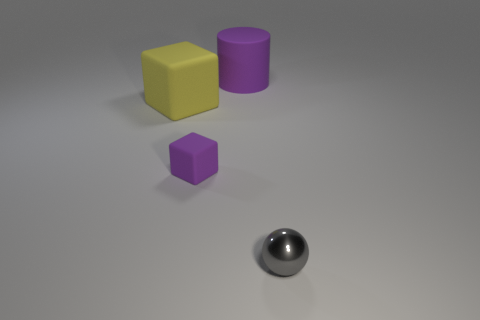Add 2 yellow objects. How many objects exist? 6 Subtract all green balls. Subtract all brown cylinders. How many balls are left? 1 Subtract all cyan cubes. How many gray cylinders are left? 0 Subtract all yellow blocks. Subtract all purple objects. How many objects are left? 1 Add 2 purple cylinders. How many purple cylinders are left? 3 Add 1 spheres. How many spheres exist? 2 Subtract 0 green cylinders. How many objects are left? 4 Subtract all cylinders. How many objects are left? 3 